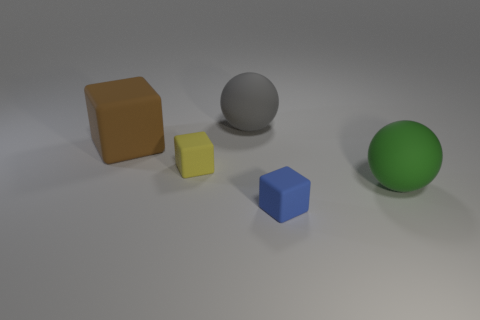There is a matte sphere on the right side of the large sphere that is to the left of the blue matte block; what is its size? The sphere on the right side of the large sphere, which is to the left of the blue block, appears to be medium-sized in comparison to the other objects in the image. 